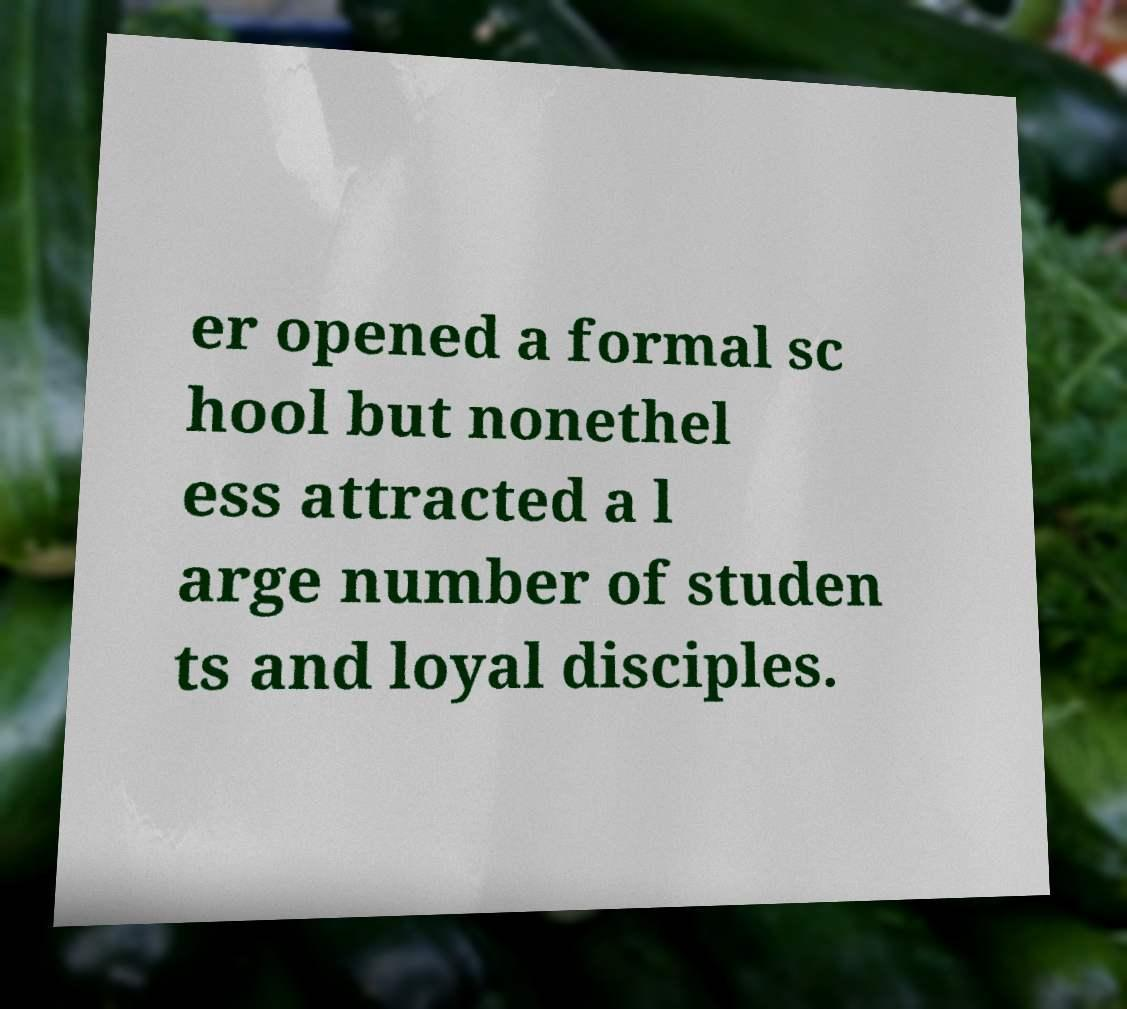For documentation purposes, I need the text within this image transcribed. Could you provide that? er opened a formal sc hool but nonethel ess attracted a l arge number of studen ts and loyal disciples. 